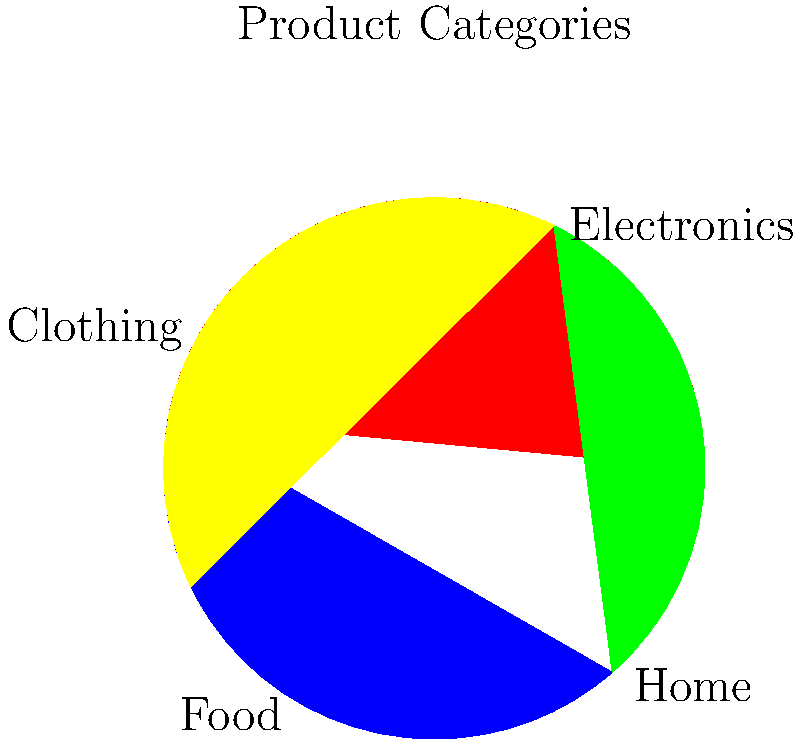In a machine learning model for classifying products based on their visual features in product images, which of the following techniques would be most appropriate for feature extraction and why?

A) Principal Component Analysis (PCA)
B) Convolutional Neural Networks (CNNs)
C) Linear Discriminant Analysis (LDA)
D) Random Forest To classify products based on their visual features in product images, we need to consider the following steps:

1. Feature extraction: This is crucial for image classification tasks.
2. High-dimensional data: Images typically contain a large number of pixels, resulting in high-dimensional data.
3. Spatial relationships: The spatial relationships between pixels are important for identifying objects in images.
4. Hierarchical features: Visual features often have a hierarchical structure, from simple edges to complex shapes.

Let's analyze each option:

A) Principal Component Analysis (PCA):
   - PCA is good for dimensionality reduction but doesn't capture spatial relationships in images.
   - It's not specifically designed for image processing tasks.

B) Convolutional Neural Networks (CNNs):
   - CNNs are specifically designed for processing grid-like data, such as images.
   - They use convolutional layers to capture spatial relationships and hierarchical features.
   - CNNs can automatically learn relevant features from raw pixel data.
   - They have shown state-of-the-art performance in various image classification tasks.

C) Linear Discriminant Analysis (LDA):
   - LDA is primarily used for dimensionality reduction and classification.
   - It's not specifically designed for image processing and doesn't capture spatial relationships.

D) Random Forest:
   - Random Forest is an ensemble learning method for classification and regression.
   - While it can be used for image classification, it doesn't inherently capture spatial relationships or hierarchical features in images.

Given these considerations, Convolutional Neural Networks (CNNs) are the most appropriate technique for feature extraction in this scenario. CNNs are specifically designed to handle image data, can capture spatial relationships, and learn hierarchical features automatically from raw pixel data.
Answer: Convolutional Neural Networks (CNNs) 